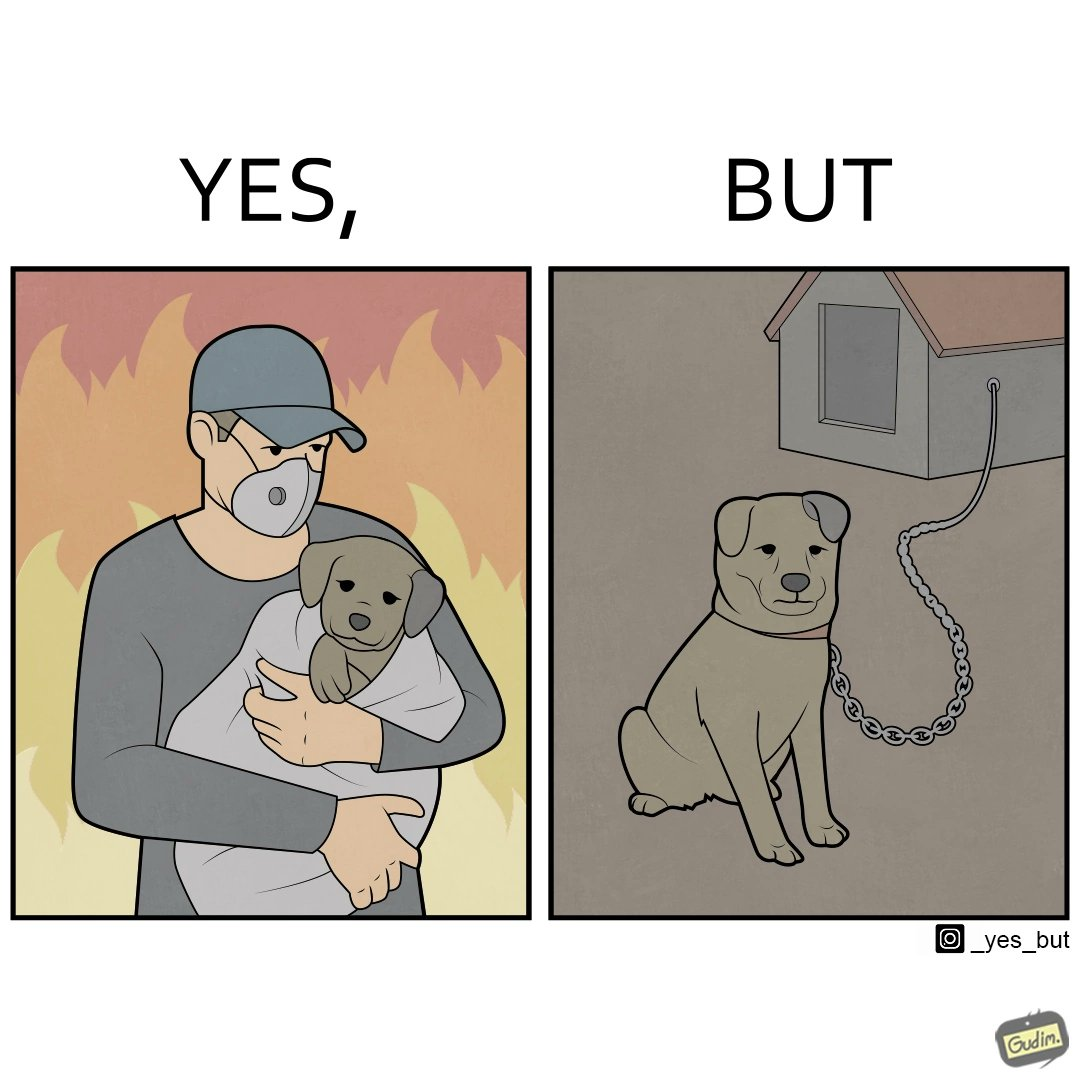What is the satirical meaning behind this image? The image is ironic, because in the left image the man is showing love and care for the puppy but in the right image the same puppy is shown to be chained in a kennel, which shows dual nature of human towards animals 